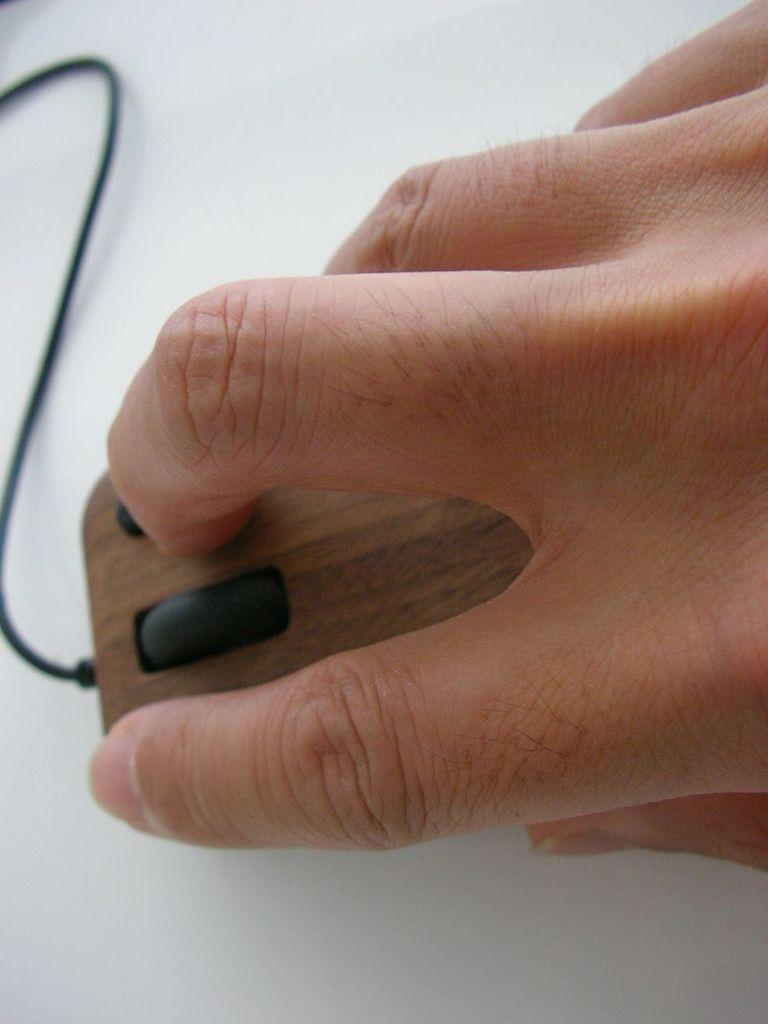What part of a person's body is visible in the image? There is a person's hand visible in the image. What is the hand holding? The hand is holding a mouse. Where is the mouse placed in the image? The mouse is on a surface. What type of sheet is covering the mouse in the image? There is no sheet covering the mouse in the image. How does the person increase the volume of the mouse in the image? The image does not show any action to increase the volume of the mouse, as it is a physical object and not an electronic device. 